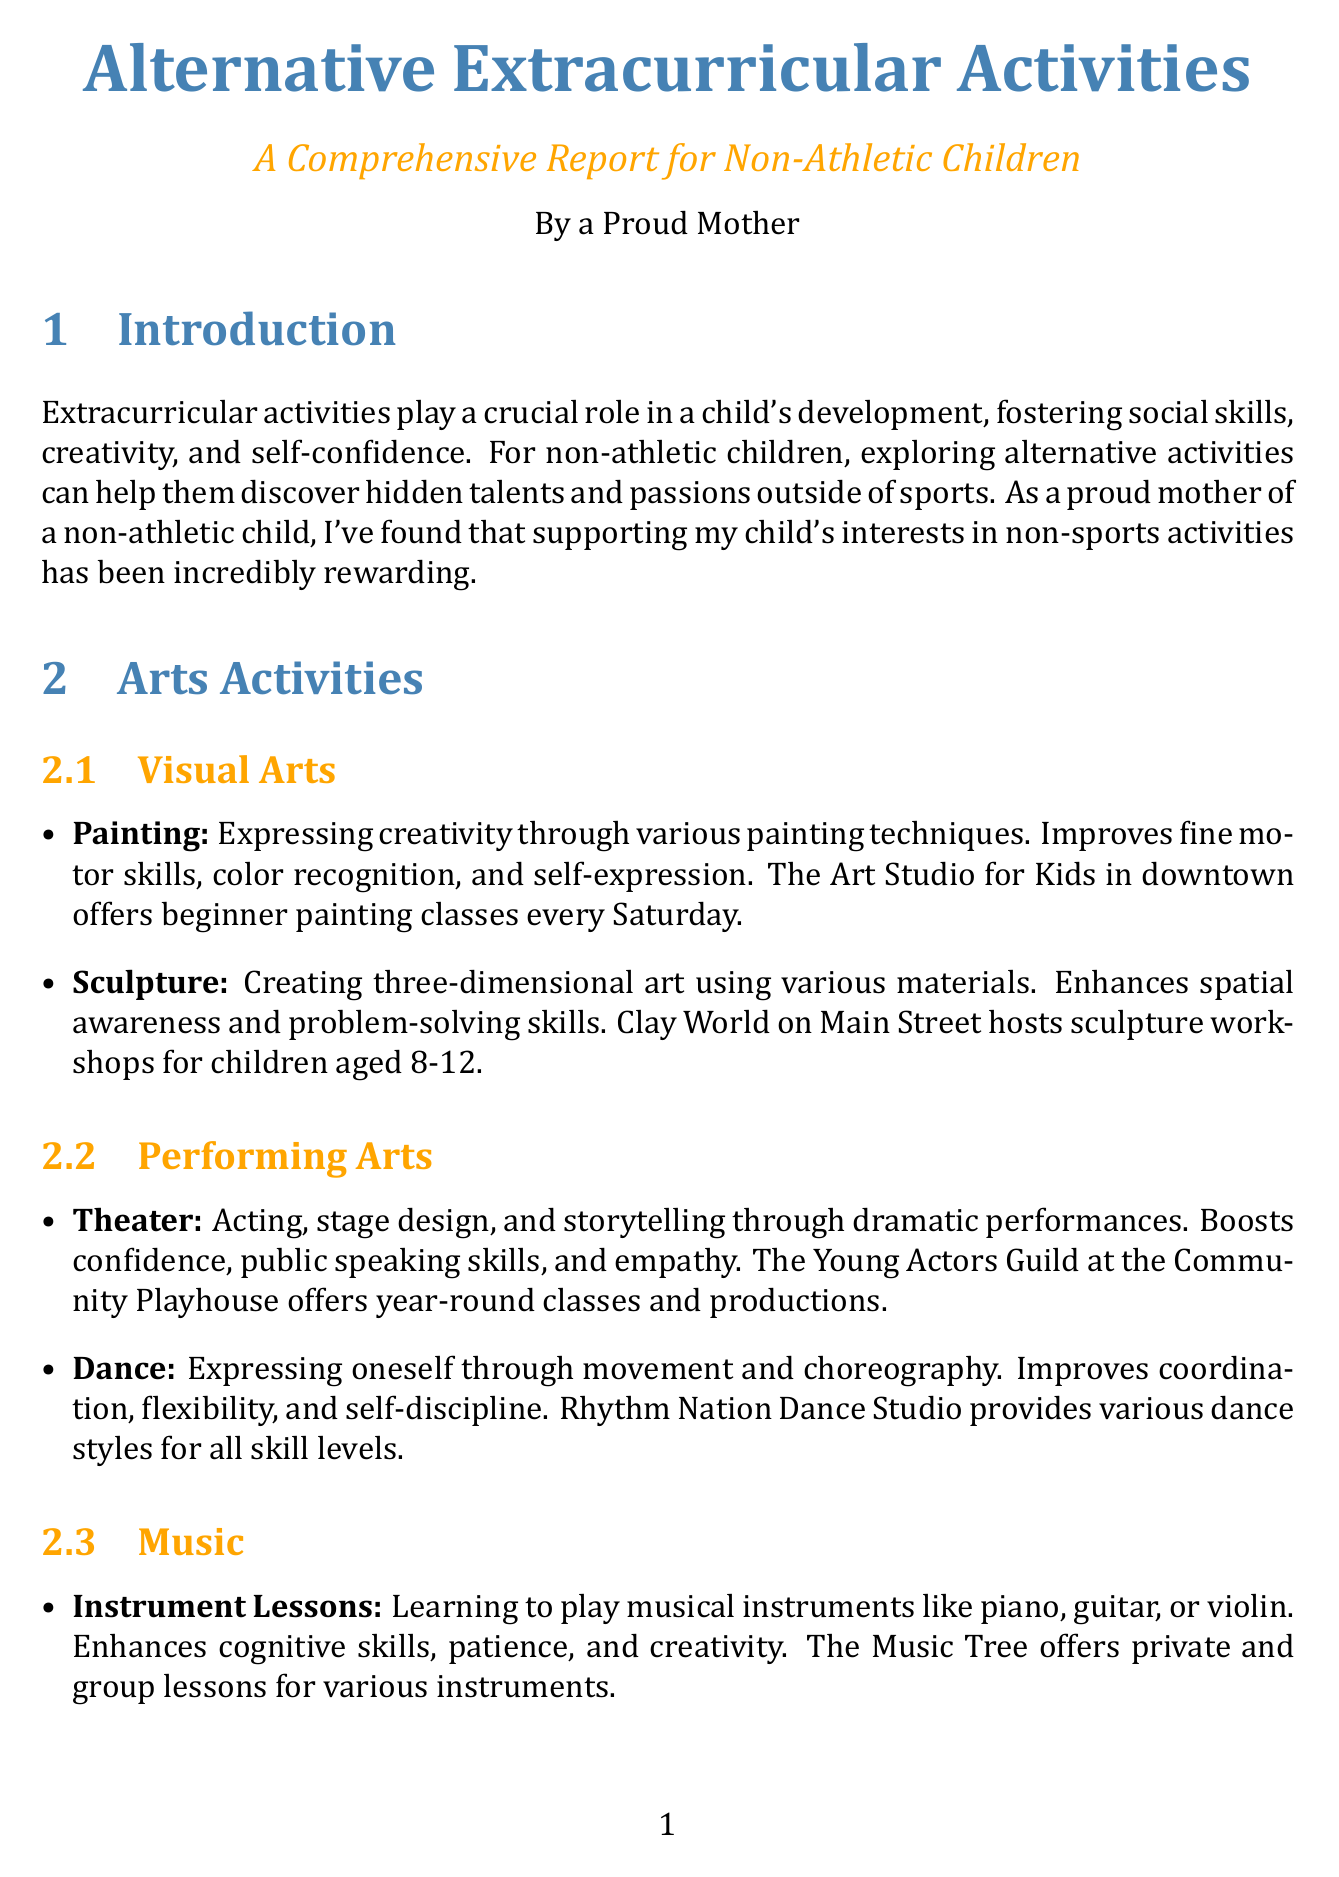What are the main benefits of extracurricular activities? The document states that extracurricular activities foster social skills, creativity, and self-confidence.
Answer: Social skills, creativity, and self-confidence What local resource offers beginner painting classes? The document lists The Art Studio for Kids in downtown as a local resource for beginner painting classes.
Answer: The Art Studio for Kids What is one benefit of learning to play musical instruments? The document notes that learning musical instruments enhances cognitive skills, patience, and creativity.
Answer: Cognitive skills, patience, and creativity How often does the Stargazers Club meet? The document states that the Stargazers Club meets monthly.
Answer: Monthly What age group does the Little Chefs Academy serve? The document specifies that Little Chefs Academy offers weekly cooking classes for children aged 8-14.
Answer: Age 8-14 What type of skills does coding classes improve? The document mentions that coding classes improve logical thinking, creativity, and problem-solving skills.
Answer: Logical thinking, creativity, and problem-solving Which activity is specifically targeted at developing teamwork and collaboration skills? The document specifies that video game design improves storytelling, problem-solving, and collaboration skills.
Answer: Video game design What is the role of supporting non-athletic interests according to the document? The conclusion states that supporting non-athletic interests has led to increased confidence and a well-rounded skill set.
Answer: Increased confidence and a well-rounded skill set Which activity provided by The Young Writers Workshop focuses on self-expression? The creative writing section highlights exploring various forms of writing to enhance self-expression.
Answer: Creative writing 